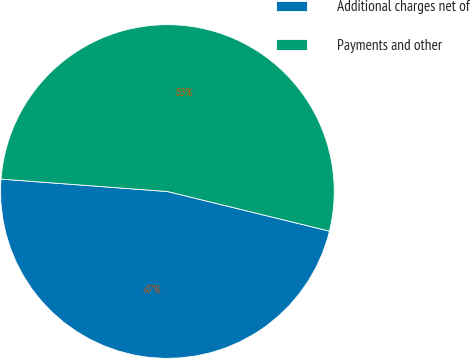Convert chart to OTSL. <chart><loc_0><loc_0><loc_500><loc_500><pie_chart><fcel>Additional charges net of<fcel>Payments and other<nl><fcel>47.37%<fcel>52.63%<nl></chart> 